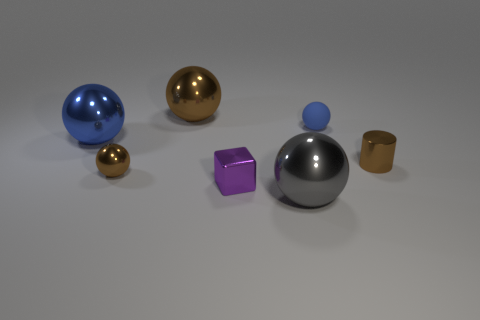Subtract all blue spheres. How many spheres are left? 3 Subtract 1 balls. How many balls are left? 4 Subtract all large brown metal spheres. How many spheres are left? 4 Add 1 tiny red matte cylinders. How many objects exist? 8 Subtract all red balls. Subtract all green cubes. How many balls are left? 5 Subtract all cylinders. How many objects are left? 6 Add 2 green matte blocks. How many green matte blocks exist? 2 Subtract 0 brown cubes. How many objects are left? 7 Subtract all blue metallic objects. Subtract all large blue metallic things. How many objects are left? 5 Add 4 metal cylinders. How many metal cylinders are left? 5 